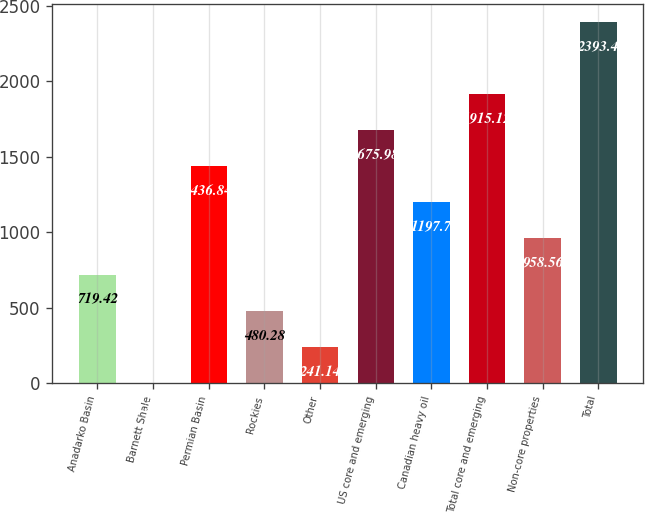Convert chart. <chart><loc_0><loc_0><loc_500><loc_500><bar_chart><fcel>Anadarko Basin<fcel>Barnett Shale<fcel>Permian Basin<fcel>Rockies<fcel>Other<fcel>US core and emerging<fcel>Canadian heavy oil<fcel>Total core and emerging<fcel>Non-core properties<fcel>Total<nl><fcel>719.42<fcel>2<fcel>1436.84<fcel>480.28<fcel>241.14<fcel>1675.98<fcel>1197.7<fcel>1915.12<fcel>958.56<fcel>2393.4<nl></chart> 